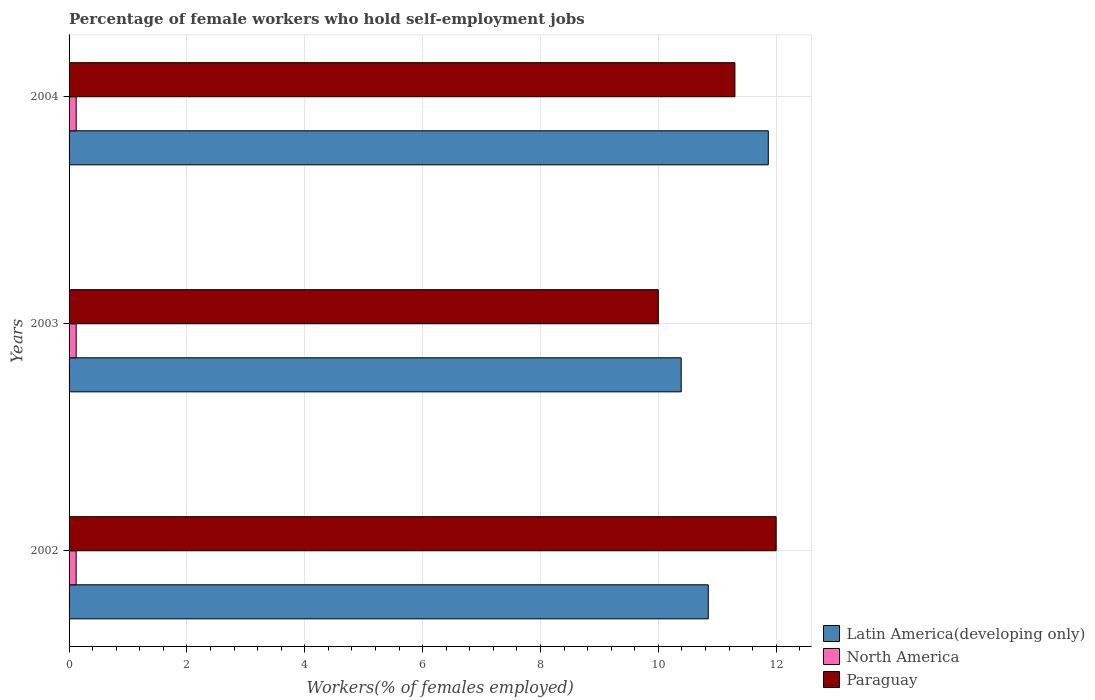How many different coloured bars are there?
Offer a terse response. 3. Are the number of bars per tick equal to the number of legend labels?
Keep it short and to the point. Yes. How many bars are there on the 1st tick from the top?
Offer a terse response. 3. In how many cases, is the number of bars for a given year not equal to the number of legend labels?
Give a very brief answer. 0. What is the percentage of self-employed female workers in Latin America(developing only) in 2004?
Offer a terse response. 11.87. Across all years, what is the minimum percentage of self-employed female workers in Latin America(developing only)?
Offer a terse response. 10.39. In which year was the percentage of self-employed female workers in Paraguay maximum?
Your answer should be compact. 2002. In which year was the percentage of self-employed female workers in Paraguay minimum?
Your answer should be very brief. 2003. What is the total percentage of self-employed female workers in North America in the graph?
Give a very brief answer. 0.36. What is the difference between the percentage of self-employed female workers in North America in 2002 and that in 2003?
Your response must be concise. -0. What is the difference between the percentage of self-employed female workers in Paraguay in 2004 and the percentage of self-employed female workers in Latin America(developing only) in 2003?
Keep it short and to the point. 0.91. What is the average percentage of self-employed female workers in Latin America(developing only) per year?
Provide a short and direct response. 11.03. In the year 2002, what is the difference between the percentage of self-employed female workers in Paraguay and percentage of self-employed female workers in North America?
Your response must be concise. 11.88. What is the ratio of the percentage of self-employed female workers in Latin America(developing only) in 2003 to that in 2004?
Keep it short and to the point. 0.88. Is the difference between the percentage of self-employed female workers in Paraguay in 2003 and 2004 greater than the difference between the percentage of self-employed female workers in North America in 2003 and 2004?
Your response must be concise. No. What is the difference between the highest and the second highest percentage of self-employed female workers in Paraguay?
Your answer should be compact. 0.7. What is the difference between the highest and the lowest percentage of self-employed female workers in Latin America(developing only)?
Keep it short and to the point. 1.48. In how many years, is the percentage of self-employed female workers in North America greater than the average percentage of self-employed female workers in North America taken over all years?
Give a very brief answer. 2. What does the 3rd bar from the bottom in 2004 represents?
Keep it short and to the point. Paraguay. Is it the case that in every year, the sum of the percentage of self-employed female workers in Latin America(developing only) and percentage of self-employed female workers in North America is greater than the percentage of self-employed female workers in Paraguay?
Ensure brevity in your answer.  No. Are all the bars in the graph horizontal?
Provide a succinct answer. Yes. How many years are there in the graph?
Offer a very short reply. 3. Are the values on the major ticks of X-axis written in scientific E-notation?
Your answer should be very brief. No. Does the graph contain grids?
Make the answer very short. Yes. What is the title of the graph?
Offer a terse response. Percentage of female workers who hold self-employment jobs. Does "Equatorial Guinea" appear as one of the legend labels in the graph?
Your answer should be compact. No. What is the label or title of the X-axis?
Offer a very short reply. Workers(% of females employed). What is the Workers(% of females employed) of Latin America(developing only) in 2002?
Give a very brief answer. 10.85. What is the Workers(% of females employed) in North America in 2002?
Offer a very short reply. 0.12. What is the Workers(% of females employed) in Latin America(developing only) in 2003?
Give a very brief answer. 10.39. What is the Workers(% of females employed) in North America in 2003?
Offer a very short reply. 0.12. What is the Workers(% of females employed) of Paraguay in 2003?
Keep it short and to the point. 10. What is the Workers(% of females employed) of Latin America(developing only) in 2004?
Provide a succinct answer. 11.87. What is the Workers(% of females employed) in North America in 2004?
Make the answer very short. 0.12. What is the Workers(% of females employed) of Paraguay in 2004?
Offer a very short reply. 11.3. Across all years, what is the maximum Workers(% of females employed) of Latin America(developing only)?
Ensure brevity in your answer.  11.87. Across all years, what is the maximum Workers(% of females employed) in North America?
Make the answer very short. 0.12. Across all years, what is the maximum Workers(% of females employed) of Paraguay?
Provide a short and direct response. 12. Across all years, what is the minimum Workers(% of females employed) of Latin America(developing only)?
Offer a very short reply. 10.39. Across all years, what is the minimum Workers(% of females employed) in North America?
Offer a terse response. 0.12. Across all years, what is the minimum Workers(% of females employed) of Paraguay?
Provide a succinct answer. 10. What is the total Workers(% of females employed) of Latin America(developing only) in the graph?
Provide a succinct answer. 33.1. What is the total Workers(% of females employed) of North America in the graph?
Keep it short and to the point. 0.36. What is the total Workers(% of females employed) of Paraguay in the graph?
Provide a short and direct response. 33.3. What is the difference between the Workers(% of females employed) in Latin America(developing only) in 2002 and that in 2003?
Ensure brevity in your answer.  0.46. What is the difference between the Workers(% of females employed) of North America in 2002 and that in 2003?
Give a very brief answer. -0. What is the difference between the Workers(% of females employed) in Paraguay in 2002 and that in 2003?
Offer a very short reply. 2. What is the difference between the Workers(% of females employed) in Latin America(developing only) in 2002 and that in 2004?
Keep it short and to the point. -1.02. What is the difference between the Workers(% of females employed) in North America in 2002 and that in 2004?
Make the answer very short. -0. What is the difference between the Workers(% of females employed) of Paraguay in 2002 and that in 2004?
Your response must be concise. 0.7. What is the difference between the Workers(% of females employed) in Latin America(developing only) in 2003 and that in 2004?
Provide a short and direct response. -1.48. What is the difference between the Workers(% of females employed) in North America in 2003 and that in 2004?
Ensure brevity in your answer.  -0. What is the difference between the Workers(% of females employed) in Latin America(developing only) in 2002 and the Workers(% of females employed) in North America in 2003?
Provide a succinct answer. 10.73. What is the difference between the Workers(% of females employed) of Latin America(developing only) in 2002 and the Workers(% of females employed) of Paraguay in 2003?
Your answer should be compact. 0.85. What is the difference between the Workers(% of females employed) of North America in 2002 and the Workers(% of females employed) of Paraguay in 2003?
Your response must be concise. -9.88. What is the difference between the Workers(% of females employed) of Latin America(developing only) in 2002 and the Workers(% of females employed) of North America in 2004?
Offer a very short reply. 10.73. What is the difference between the Workers(% of females employed) in Latin America(developing only) in 2002 and the Workers(% of females employed) in Paraguay in 2004?
Keep it short and to the point. -0.45. What is the difference between the Workers(% of females employed) in North America in 2002 and the Workers(% of females employed) in Paraguay in 2004?
Offer a terse response. -11.18. What is the difference between the Workers(% of females employed) of Latin America(developing only) in 2003 and the Workers(% of females employed) of North America in 2004?
Provide a succinct answer. 10.27. What is the difference between the Workers(% of females employed) in Latin America(developing only) in 2003 and the Workers(% of females employed) in Paraguay in 2004?
Offer a terse response. -0.91. What is the difference between the Workers(% of females employed) in North America in 2003 and the Workers(% of females employed) in Paraguay in 2004?
Give a very brief answer. -11.18. What is the average Workers(% of females employed) in Latin America(developing only) per year?
Provide a short and direct response. 11.03. What is the average Workers(% of females employed) in North America per year?
Make the answer very short. 0.12. In the year 2002, what is the difference between the Workers(% of females employed) in Latin America(developing only) and Workers(% of females employed) in North America?
Offer a very short reply. 10.73. In the year 2002, what is the difference between the Workers(% of females employed) in Latin America(developing only) and Workers(% of females employed) in Paraguay?
Ensure brevity in your answer.  -1.15. In the year 2002, what is the difference between the Workers(% of females employed) in North America and Workers(% of females employed) in Paraguay?
Your answer should be very brief. -11.88. In the year 2003, what is the difference between the Workers(% of females employed) of Latin America(developing only) and Workers(% of females employed) of North America?
Keep it short and to the point. 10.27. In the year 2003, what is the difference between the Workers(% of females employed) of Latin America(developing only) and Workers(% of females employed) of Paraguay?
Offer a terse response. 0.39. In the year 2003, what is the difference between the Workers(% of females employed) of North America and Workers(% of females employed) of Paraguay?
Your answer should be very brief. -9.88. In the year 2004, what is the difference between the Workers(% of females employed) of Latin America(developing only) and Workers(% of females employed) of North America?
Ensure brevity in your answer.  11.75. In the year 2004, what is the difference between the Workers(% of females employed) of Latin America(developing only) and Workers(% of females employed) of Paraguay?
Your answer should be very brief. 0.57. In the year 2004, what is the difference between the Workers(% of females employed) of North America and Workers(% of females employed) of Paraguay?
Offer a terse response. -11.18. What is the ratio of the Workers(% of females employed) in Latin America(developing only) in 2002 to that in 2003?
Keep it short and to the point. 1.04. What is the ratio of the Workers(% of females employed) of Latin America(developing only) in 2002 to that in 2004?
Make the answer very short. 0.91. What is the ratio of the Workers(% of females employed) of Paraguay in 2002 to that in 2004?
Give a very brief answer. 1.06. What is the ratio of the Workers(% of females employed) in Latin America(developing only) in 2003 to that in 2004?
Offer a terse response. 0.88. What is the ratio of the Workers(% of females employed) of Paraguay in 2003 to that in 2004?
Your response must be concise. 0.89. What is the difference between the highest and the second highest Workers(% of females employed) in Latin America(developing only)?
Keep it short and to the point. 1.02. What is the difference between the highest and the second highest Workers(% of females employed) in Paraguay?
Ensure brevity in your answer.  0.7. What is the difference between the highest and the lowest Workers(% of females employed) of Latin America(developing only)?
Offer a very short reply. 1.48. What is the difference between the highest and the lowest Workers(% of females employed) in North America?
Your answer should be very brief. 0. What is the difference between the highest and the lowest Workers(% of females employed) of Paraguay?
Provide a short and direct response. 2. 